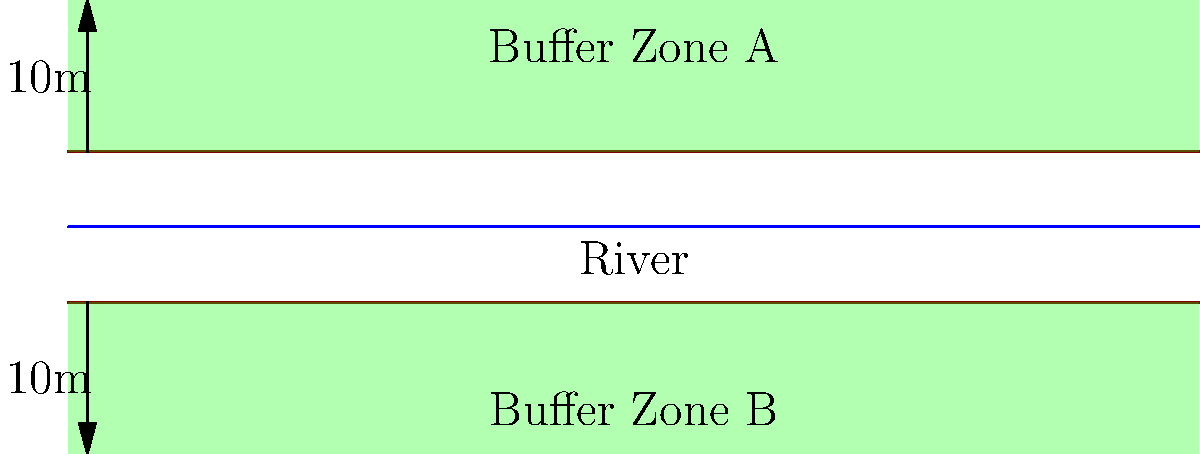Based on the cross-sectional diagram of a river with riparian buffer zones, evaluate the effectiveness of the buffer zones in protecting water quality. Consider factors such as width, vegetation density, and potential pollutant sources. How might you improve the buffer zone design to enhance its effectiveness in the Philippine context? To evaluate the effectiveness of the riparian buffer zones, we need to consider several factors:

1. Width: The diagram shows buffer zones of 10m on each side of the river. Research suggests that wider buffer zones are generally more effective. In the Philippines, the minimum required width varies depending on the stream order and land use, but it's typically between 20-100 meters.

2. Vegetation density: The diagram doesn't show specific vegetation details, but ideally, buffer zones should have dense, diverse native vegetation to maximize effectiveness.

3. Slope: The diagram shows flat buffer zones, which are generally less effective than sloped ones in filtering runoff.

4. Potential pollutant sources: The diagram doesn't show nearby land uses, which could impact buffer zone effectiveness.

5. Soil type: Not shown in the diagram, but important for determining infiltration rates and pollutant filtering capacity.

To improve the buffer zone design in the Philippine context:

1. Increase width: Expand the buffer zones to at least 20 meters on each side, or more if possible, to comply with Philippine regulations and improve effectiveness.

2. Enhance vegetation: Implement a multi-tiered vegetation structure with native species, including trees, shrubs, and grasses.

3. Incorporate slope: Design buffer zones with a gentle slope away from the river to improve runoff filtration.

4. Address local pollutant sources: Tailor the buffer zone design to specific upstream land uses and potential pollutant sources in the watershed.

5. Consider soil properties: Analyze local soil types and adjust vegetation and width accordingly to maximize pollutant removal efficiency.

6. Implement sustainable agroforestry: Integrate buffer zones with sustainable farming practices to provide both environmental and economic benefits to local communities.

7. Community involvement: Engage local communities in buffer zone maintenance and monitoring to ensure long-term effectiveness and compliance with regulations.

By implementing these improvements, the riparian buffer zones can be more effective in protecting water quality in Philippine watersheds.
Answer: Increase width to ≥20m, enhance vegetation diversity, incorporate slope, address local pollutants, consider soil properties, implement sustainable agroforestry, and involve communities. 